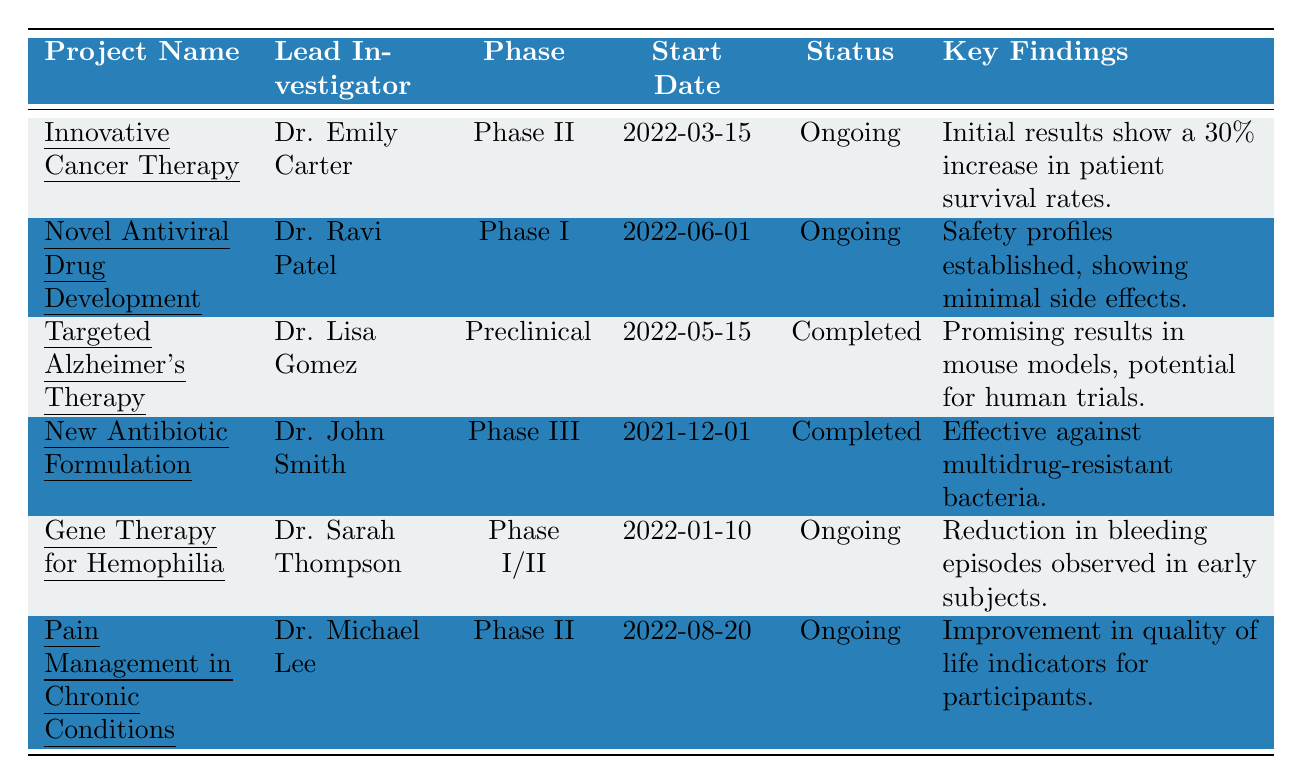What is the status of the "New Antibiotic Formulation" project? The table indicates that the "New Antibiotic Formulation" project has a status of "Completed."
Answer: Completed Who is leading the "Pain Management in Chronic Conditions" project? The table shows that Dr. Michael Lee is the lead investigator for this project.
Answer: Dr. Michael Lee What phase is the "Targeted Alzheimer's Therapy" project currently in? According to the table, the "Targeted Alzheimer's Therapy" project is in the "Preclinical" phase.
Answer: Preclinical How many projects are currently ongoing? By counting the projects with a status of "Ongoing" in the table, we see there are 4 ongoing projects: "Innovative Cancer Therapy," "Novel Antiviral Drug Development," "Gene Therapy for Hemophilia," and "Pain Management in Chronic Conditions."
Answer: 4 Is there a project in Phase III? The table confirms that there is indeed a project in Phase III: "New Antibiotic Formulation."
Answer: Yes What is the earliest start date among these projects? The earliest start date recorded in the table is "2021-12-01," linked to the "New Antibiotic Formulation" project.
Answer: 2021-12-01 Which project has shown a 30% increase in patient survival rates? According to the key findings in the table, the "Innovative Cancer Therapy" project has shown a 30% increase in patient survival rates.
Answer: Innovative Cancer Therapy How many phases are represented in the ongoing projects? The ongoing projects include Phase I, Phase II, and Phase I/II, resulting in a total of 3 distinct phases among them.
Answer: 3 What proportion of projects are completed? There are 6 projects in total and 2 completed projects, which gives a proportion of 2/6 = 1/3 or about 33.33%.
Answer: 33.33% Has the "Gene Therapy for Hemophilia" project completed its trials? The table indicates that "Gene Therapy for Hemophilia" is ongoing, and thus has not completed its trials yet.
Answer: No 